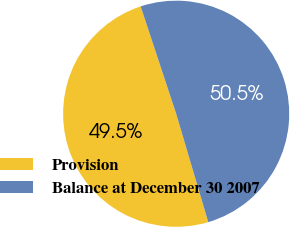Convert chart to OTSL. <chart><loc_0><loc_0><loc_500><loc_500><pie_chart><fcel>Provision<fcel>Balance at December 30 2007<nl><fcel>49.5%<fcel>50.5%<nl></chart> 